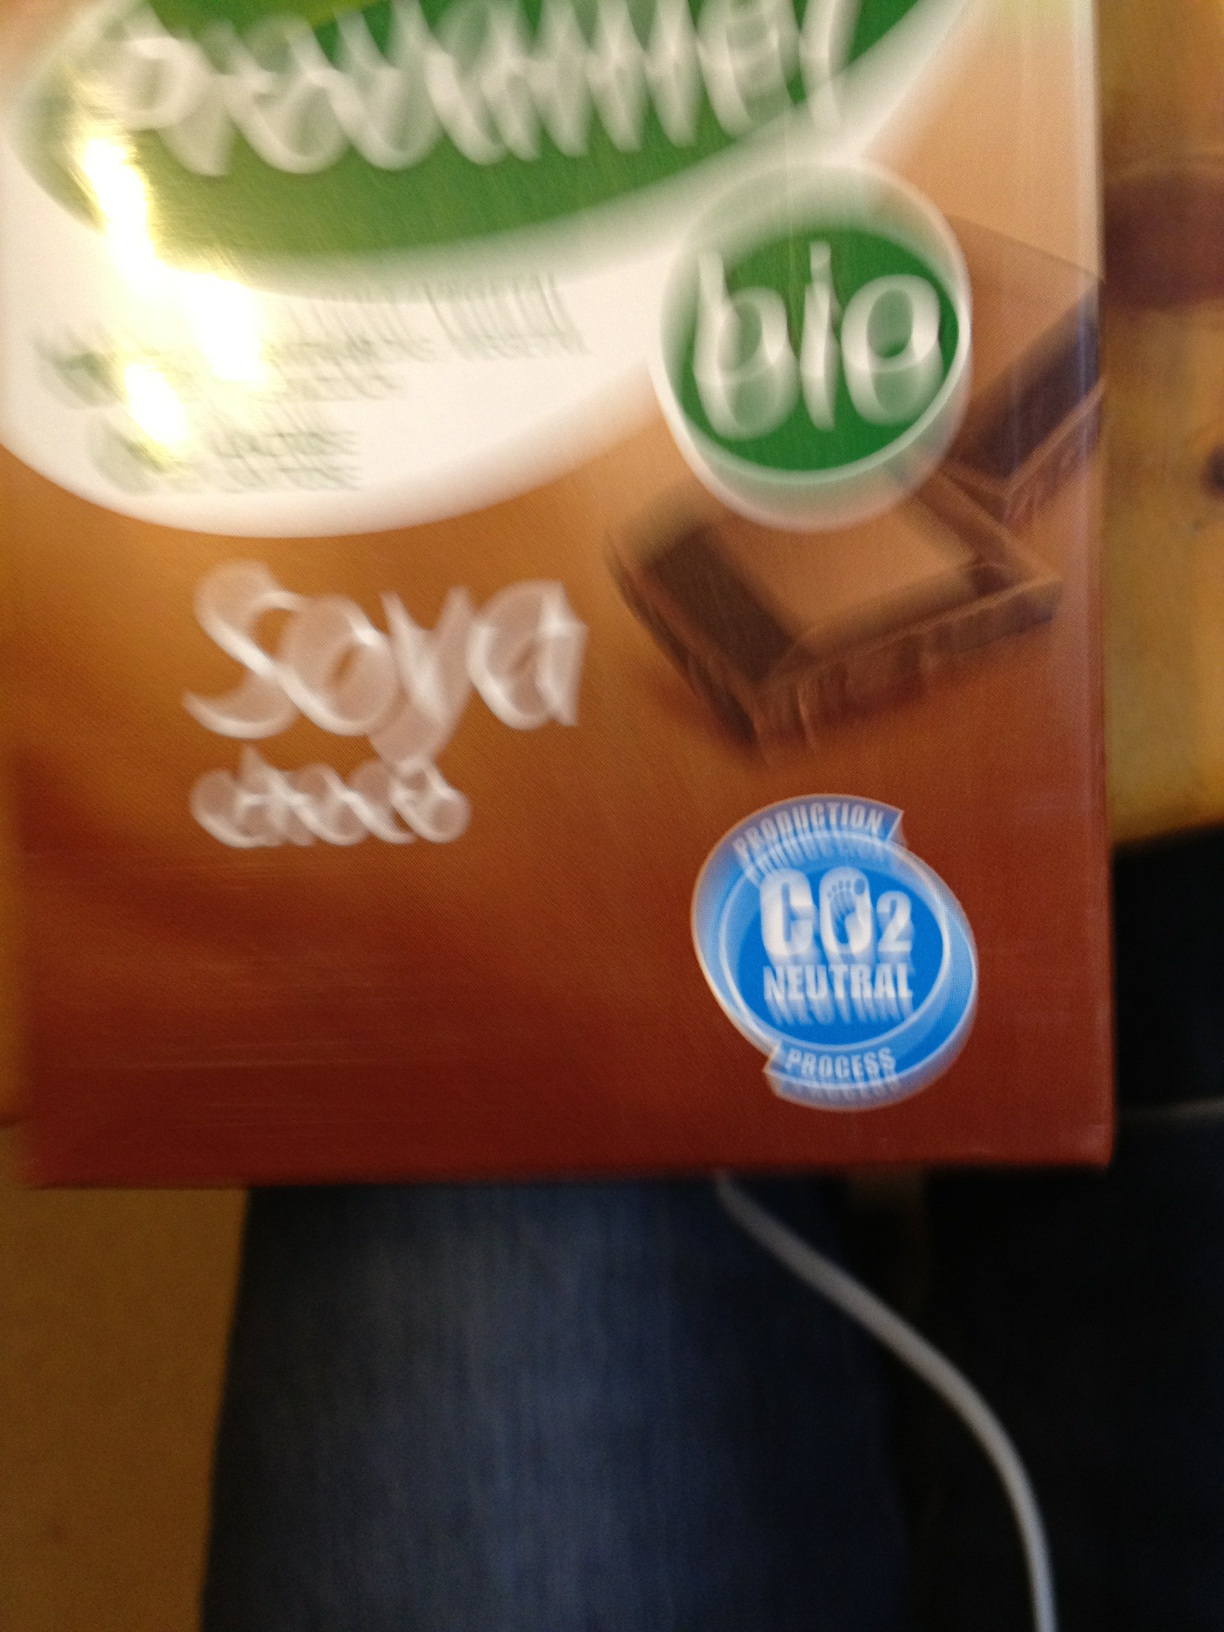Can you tell what certifications are present on the packaging shown? The image includes a logo that indicates the product is labeled 'bio', likely referring to its organic certification. Additionally, there is a 'CO2 neutral process' certification, suggesting environmental considerations in the product's production process. 